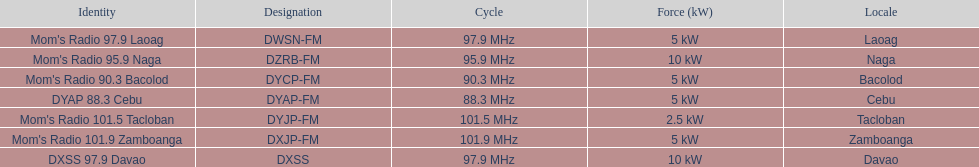How many stations broadcast with a power of 5kw? 4. 